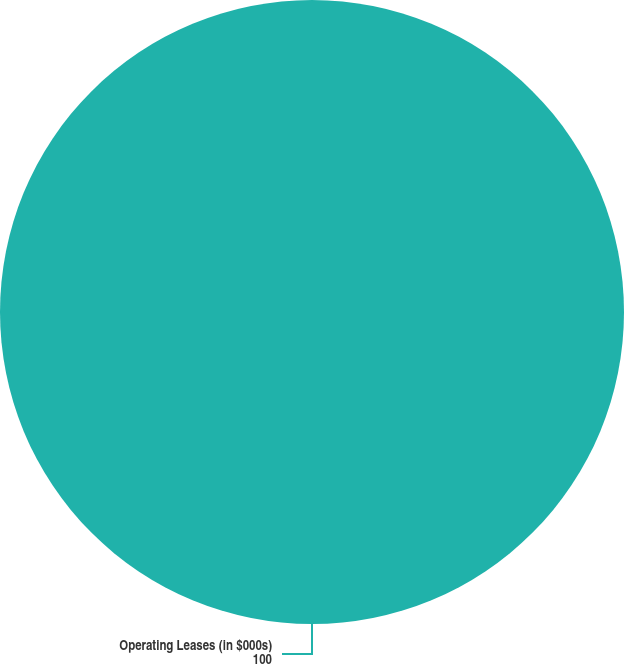Convert chart. <chart><loc_0><loc_0><loc_500><loc_500><pie_chart><fcel>Operating Leases (in $000s)<nl><fcel>100.0%<nl></chart> 